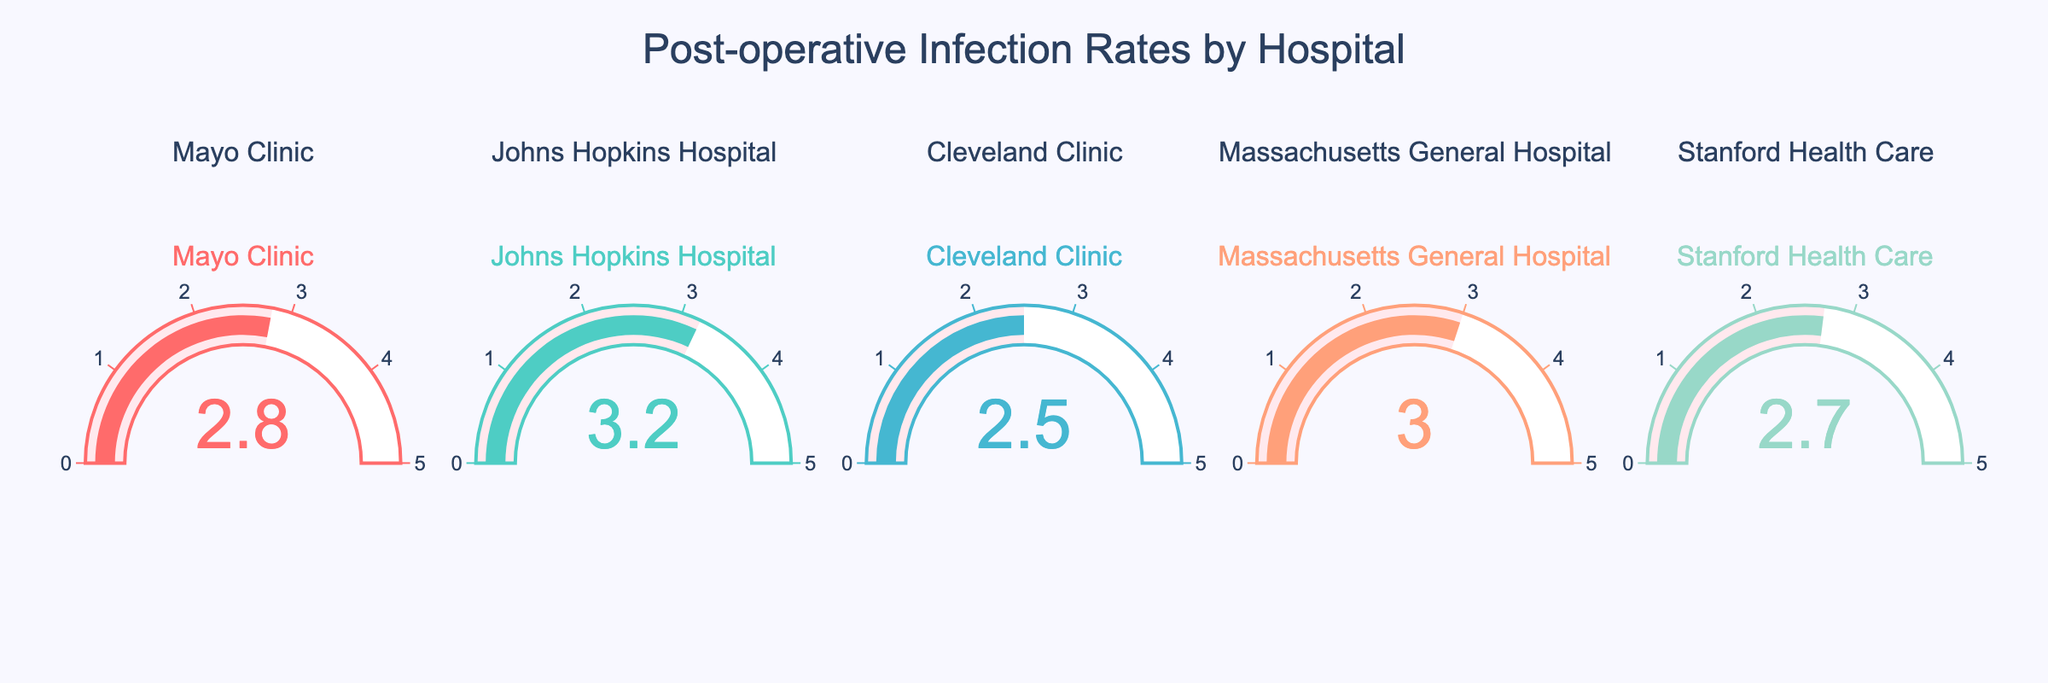How many hospitals are depicted in the figure? The figure shows gauges for different hospitals, each representing a post-operative infection rate. By counting the number of gauges and their titles, we can determine there are 5 hospitals displayed.
Answer: 5 Which hospital has the highest post-operative infection rate? To find this, compare the values displayed on each gauge. Johns Hopkins Hospital shows the highest rate at 3.2.
Answer: Johns Hopkins Hospital What's the difference in infection rates between the hospital with the highest rate and the hospital with the lowest rate? The highest rate is 3.2 (Johns Hopkins Hospital) and the lowest is 2.5 (Cleveland Clinic). The difference is calculated as 3.2 - 2.5.
Answer: 0.7 What is the average post-operative infection rate across all hospitals? Add up all the infection rates: 2.8 + 3.2 + 2.5 + 3.0 + 2.7 = 14.2. Then divide by the number of hospitals, which is 5.
Answer: 2.84 What is the combined infection rate of Mayo Clinic and Stanford Health Care? Add the respective infection rates: Mayo Clinic (2.8) + Stanford Health Care (2.7) = 5.5.
Answer: 5.5 Which hospital's gauge is represented by the lightest color? The lightest color can be visually identified from the gauge colors. Massachusetts General Hospital has the lightest-colored gauge.
Answer: Massachusetts General Hospital How many hospitals have an infection rate above 3.0? By inspecting the gauge values, only Johns Hopkins Hospital (3.2) has an infection rate above 3.0. So, the answer is 1.
Answer: 1 Is there any hospital with an infection rate of 2.9? By looking at the gauge values for all hospitals, none of the displayed infection rates are 2.9.
Answer: No What range do the gauges cover in terms of infection rate values? Each gauge indicates its value and all are within the range shown on the gauge axis, which is 0 to 5. The actual range of values displayed is from 2.5 to 3.2.
Answer: 2.5 to 3.2 